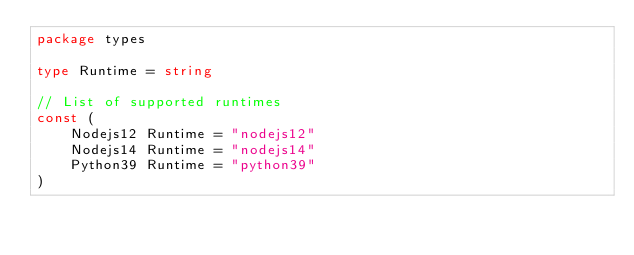<code> <loc_0><loc_0><loc_500><loc_500><_Go_>package types

type Runtime = string

// List of supported runtimes
const (
	Nodejs12 Runtime = "nodejs12"
	Nodejs14 Runtime = "nodejs14"
	Python39 Runtime = "python39"
)
</code> 